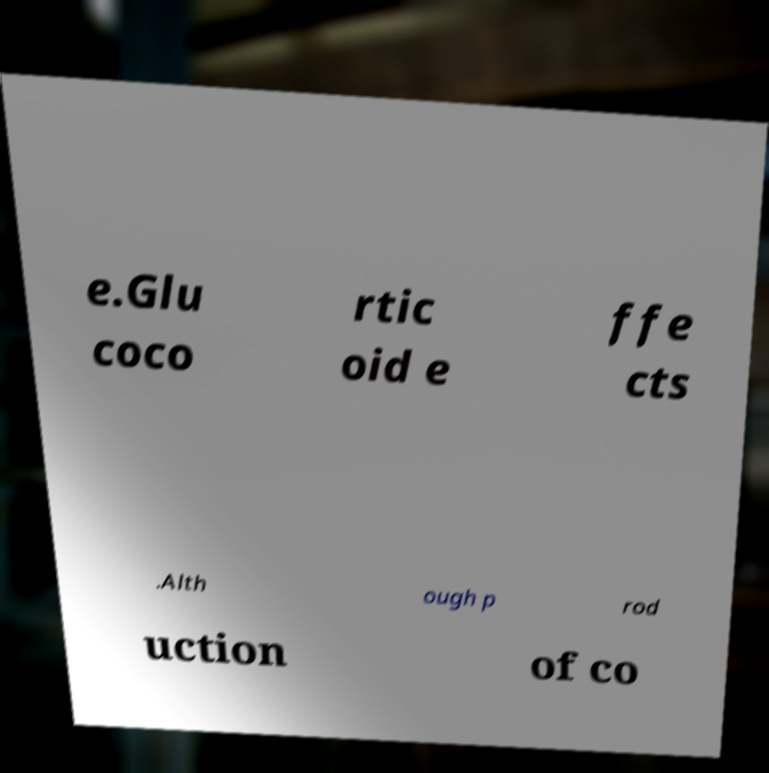Can you accurately transcribe the text from the provided image for me? e.Glu coco rtic oid e ffe cts .Alth ough p rod uction of co 